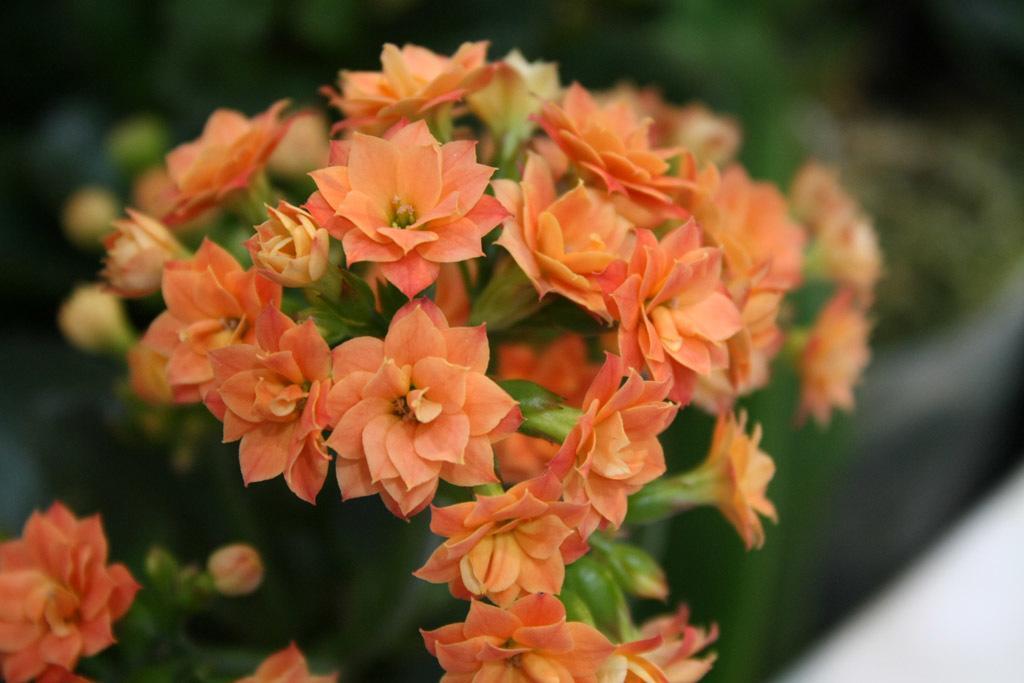In one or two sentences, can you explain what this image depicts? In the foreground of the picture there are orange flowers and buds. The background is blurred. In the background there are plants. 